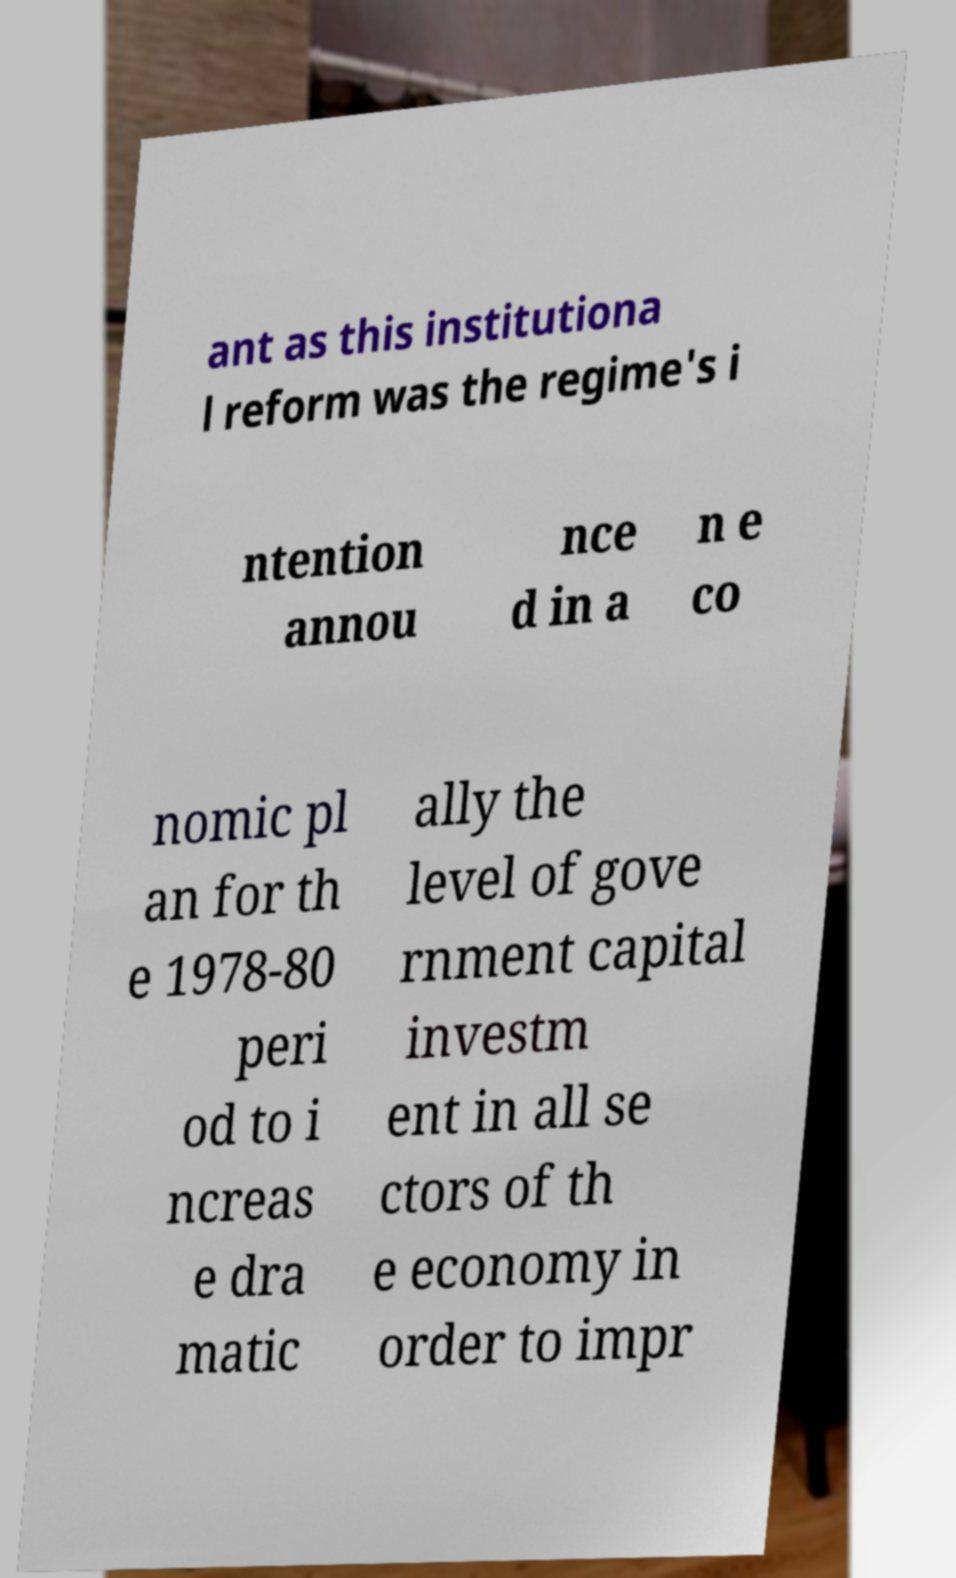Can you read and provide the text displayed in the image?This photo seems to have some interesting text. Can you extract and type it out for me? ant as this institutiona l reform was the regime's i ntention annou nce d in a n e co nomic pl an for th e 1978-80 peri od to i ncreas e dra matic ally the level of gove rnment capital investm ent in all se ctors of th e economy in order to impr 